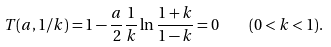<formula> <loc_0><loc_0><loc_500><loc_500>T ( a , 1 / k ) = 1 - \frac { a } { 2 } \frac { 1 } { k } \ln \frac { 1 + k } { 1 - k } = 0 \quad ( 0 < k < 1 ) .</formula> 